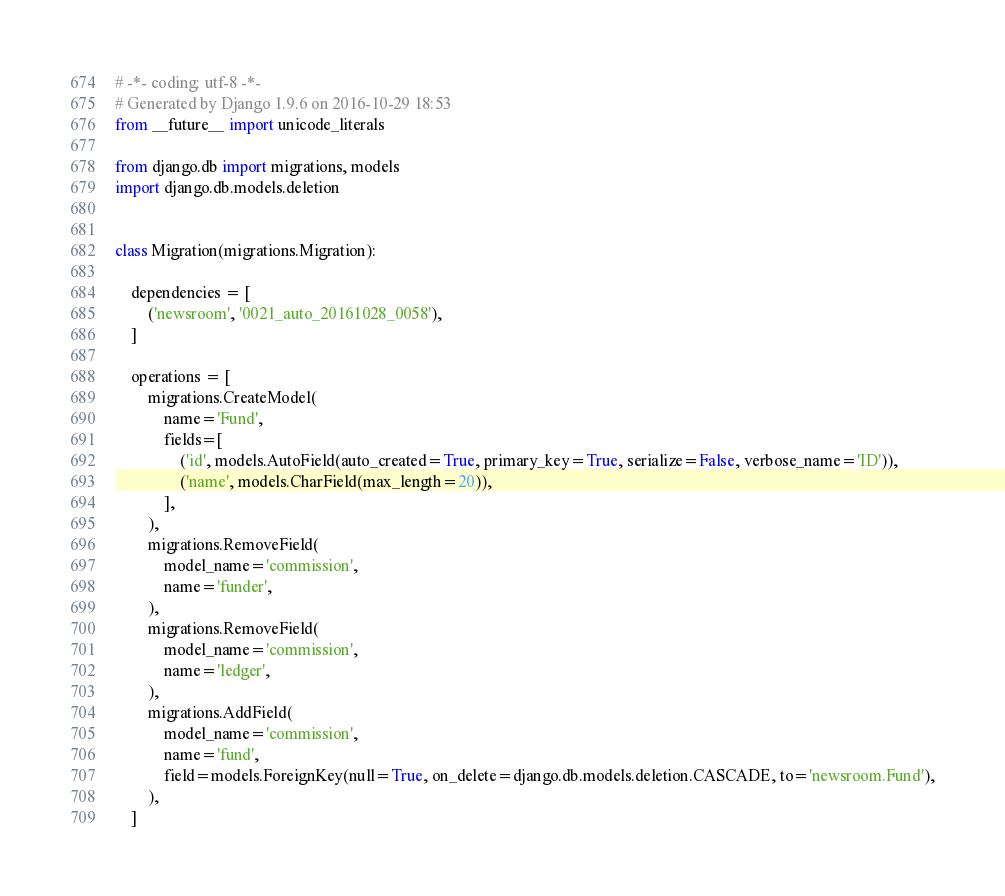Convert code to text. <code><loc_0><loc_0><loc_500><loc_500><_Python_># -*- coding: utf-8 -*-
# Generated by Django 1.9.6 on 2016-10-29 18:53
from __future__ import unicode_literals

from django.db import migrations, models
import django.db.models.deletion


class Migration(migrations.Migration):

    dependencies = [
        ('newsroom', '0021_auto_20161028_0058'),
    ]

    operations = [
        migrations.CreateModel(
            name='Fund',
            fields=[
                ('id', models.AutoField(auto_created=True, primary_key=True, serialize=False, verbose_name='ID')),
                ('name', models.CharField(max_length=20)),
            ],
        ),
        migrations.RemoveField(
            model_name='commission',
            name='funder',
        ),
        migrations.RemoveField(
            model_name='commission',
            name='ledger',
        ),
        migrations.AddField(
            model_name='commission',
            name='fund',
            field=models.ForeignKey(null=True, on_delete=django.db.models.deletion.CASCADE, to='newsroom.Fund'),
        ),
    ]
</code> 